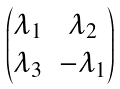<formula> <loc_0><loc_0><loc_500><loc_500>\begin{pmatrix} \lambda _ { 1 } & \lambda _ { 2 } \\ \lambda _ { 3 } & - \lambda _ { 1 } \end{pmatrix}</formula> 